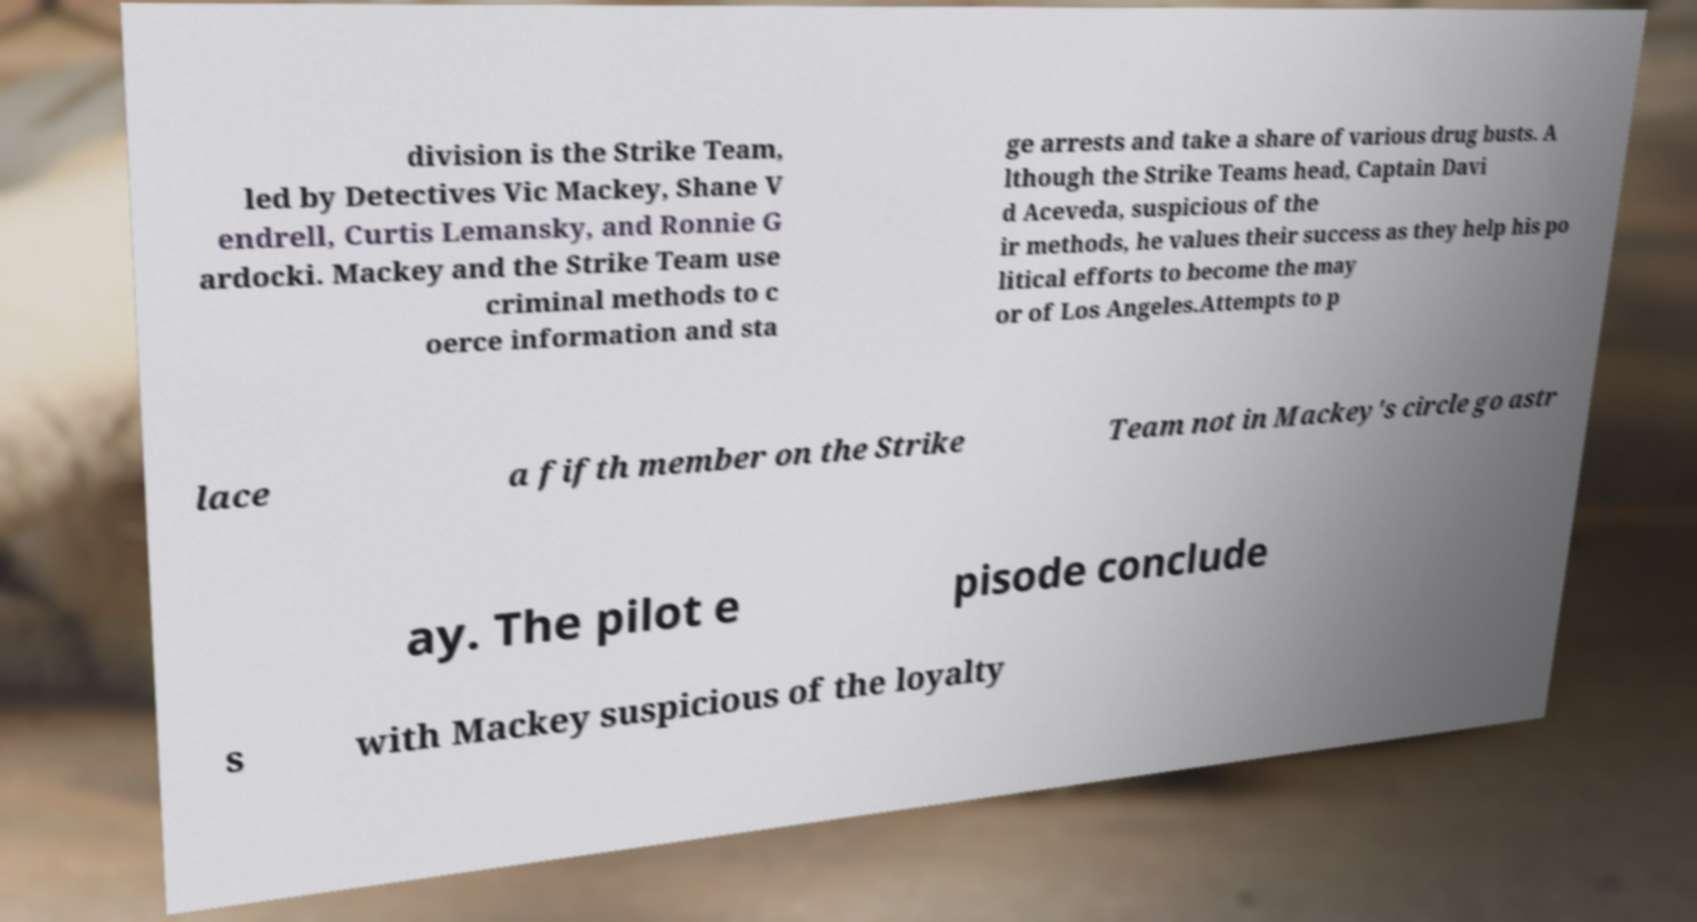Can you read and provide the text displayed in the image?This photo seems to have some interesting text. Can you extract and type it out for me? division is the Strike Team, led by Detectives Vic Mackey, Shane V endrell, Curtis Lemansky, and Ronnie G ardocki. Mackey and the Strike Team use criminal methods to c oerce information and sta ge arrests and take a share of various drug busts. A lthough the Strike Teams head, Captain Davi d Aceveda, suspicious of the ir methods, he values their success as they help his po litical efforts to become the may or of Los Angeles.Attempts to p lace a fifth member on the Strike Team not in Mackey's circle go astr ay. The pilot e pisode conclude s with Mackey suspicious of the loyalty 